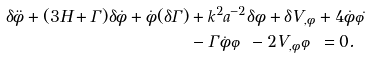<formula> <loc_0><loc_0><loc_500><loc_500>\delta \ddot { \phi } + ( 3 H + \Gamma ) \delta \dot { \phi } + \dot { \phi } ( \delta \Gamma ) & + k ^ { 2 } a ^ { - 2 } \delta \phi + \delta V _ { , \phi } + 4 \dot { \phi } \dot { \varphi } \\ & - \Gamma \dot { \phi } \varphi - 2 V _ { , \phi } \varphi = 0 .</formula> 